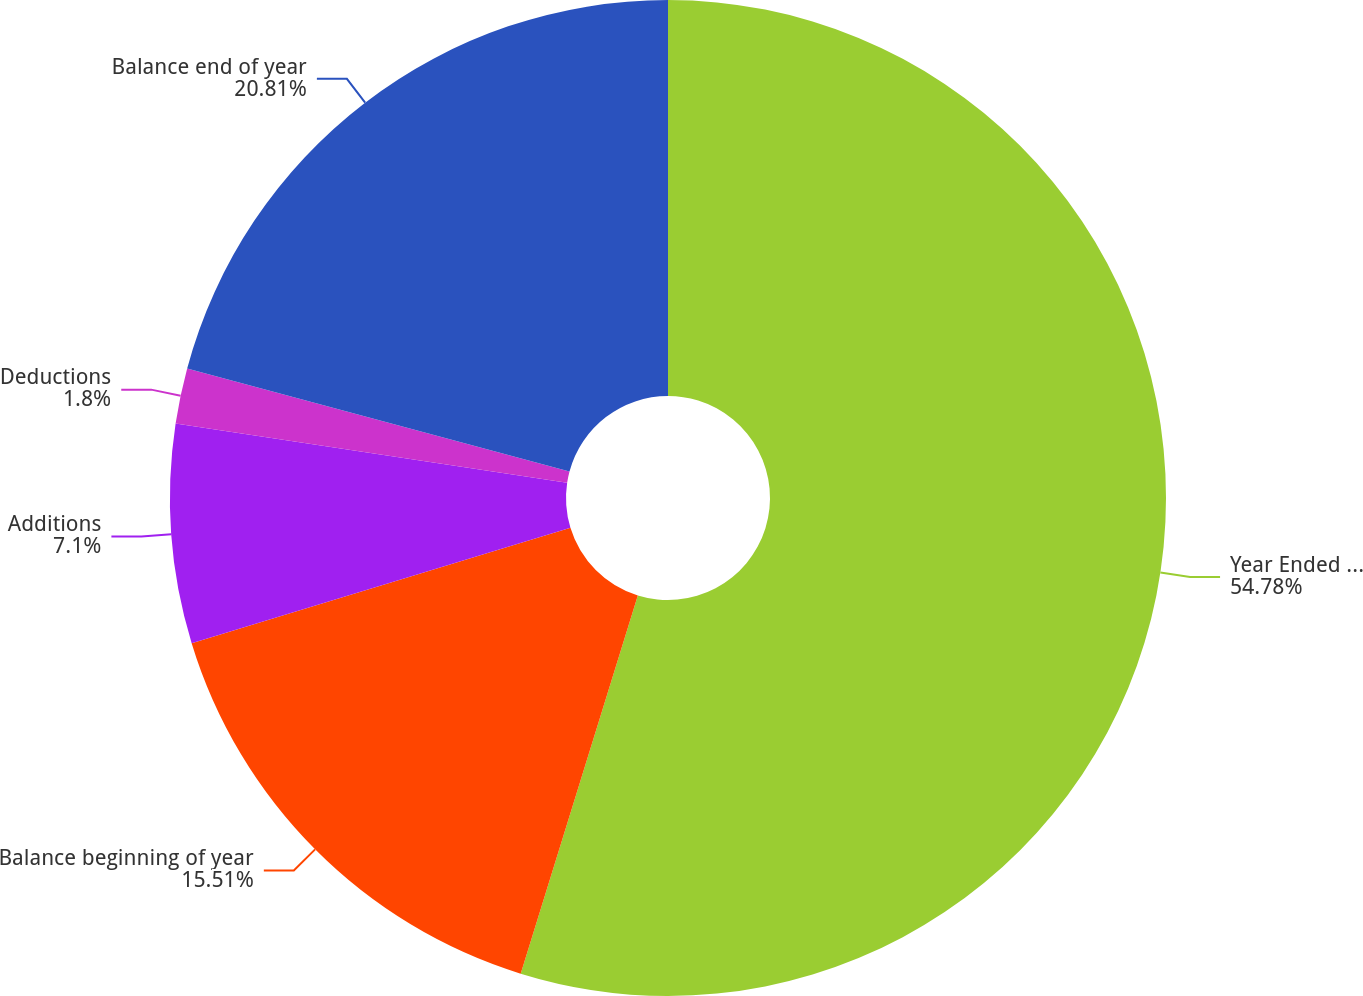Convert chart to OTSL. <chart><loc_0><loc_0><loc_500><loc_500><pie_chart><fcel>Year Ended December 31<fcel>Balance beginning of year<fcel>Additions<fcel>Deductions<fcel>Balance end of year<nl><fcel>54.78%<fcel>15.51%<fcel>7.1%<fcel>1.8%<fcel>20.81%<nl></chart> 